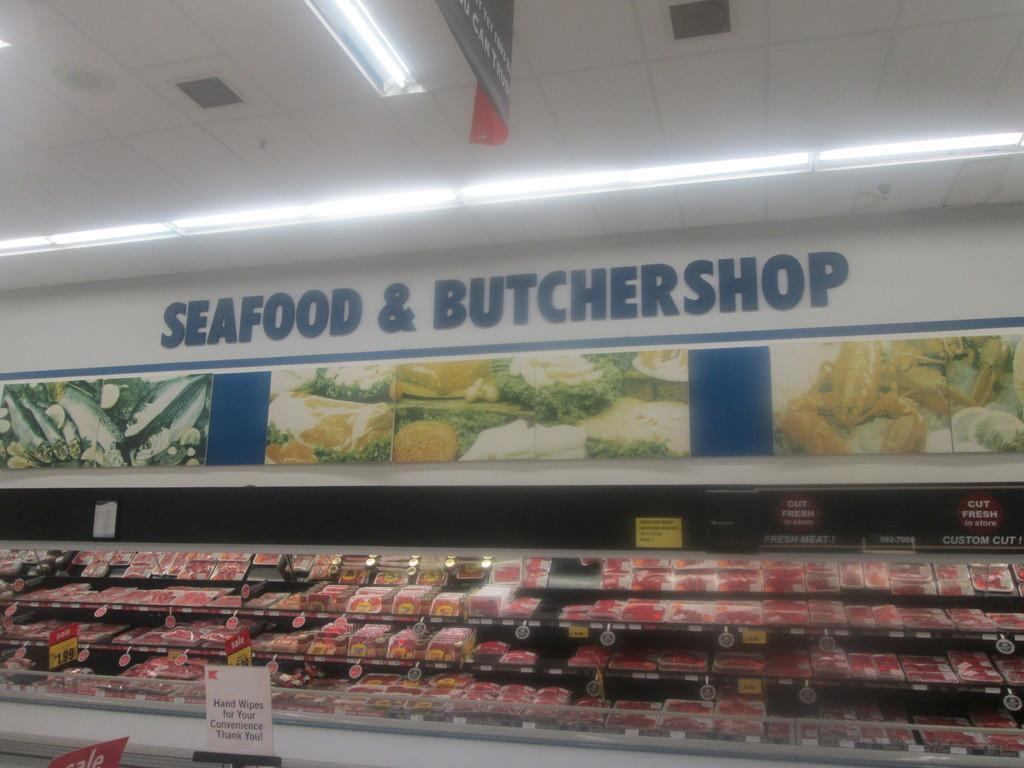<image>
Summarize the visual content of the image. The seafood & butchershop section of a grocery store. 